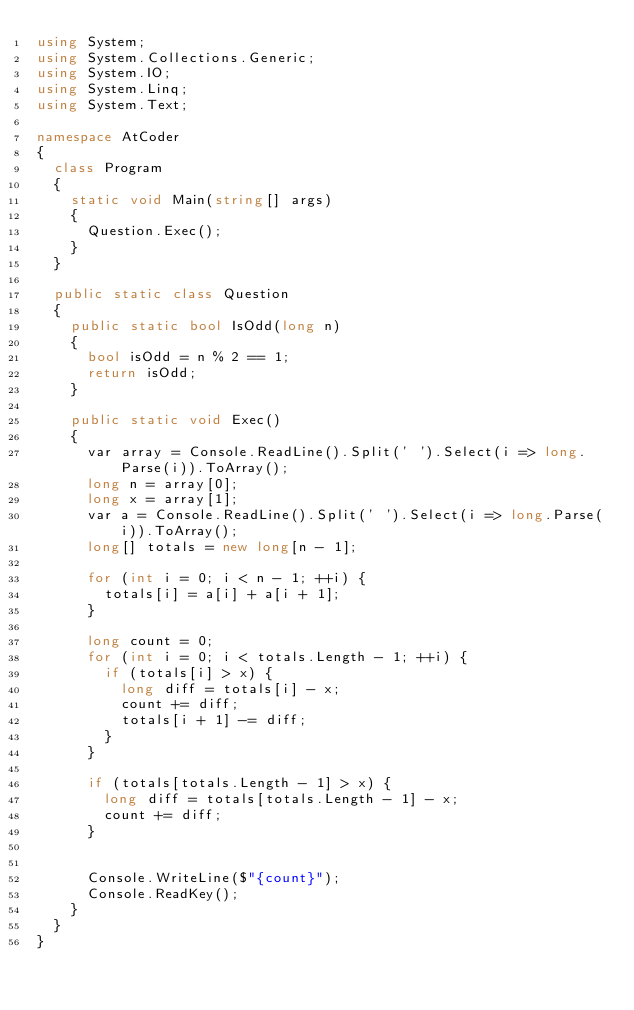<code> <loc_0><loc_0><loc_500><loc_500><_C#_>using System;
using System.Collections.Generic;
using System.IO;
using System.Linq;
using System.Text;

namespace AtCoder
{
	class Program
	{
		static void Main(string[] args)
		{
			Question.Exec();
		}
	}

	public static class Question
	{
		public static bool IsOdd(long n)
		{
			bool isOdd = n % 2 == 1;
			return isOdd;
		}

		public static void Exec()
		{
			var array = Console.ReadLine().Split(' ').Select(i => long.Parse(i)).ToArray();
			long n = array[0];
			long x = array[1];
			var a = Console.ReadLine().Split(' ').Select(i => long.Parse(i)).ToArray();
			long[] totals = new long[n - 1];

			for (int i = 0; i < n - 1; ++i) {
				totals[i] = a[i] + a[i + 1];
			}

			long count = 0;
			for (int i = 0; i < totals.Length - 1; ++i) {
				if (totals[i] > x) {
					long diff = totals[i] - x;
					count += diff;
					totals[i + 1] -= diff;
				}
			}

			if (totals[totals.Length - 1] > x) {
				long diff = totals[totals.Length - 1] - x;
				count += diff;
			}


			Console.WriteLine($"{count}");
			Console.ReadKey();
		}
	}
}</code> 